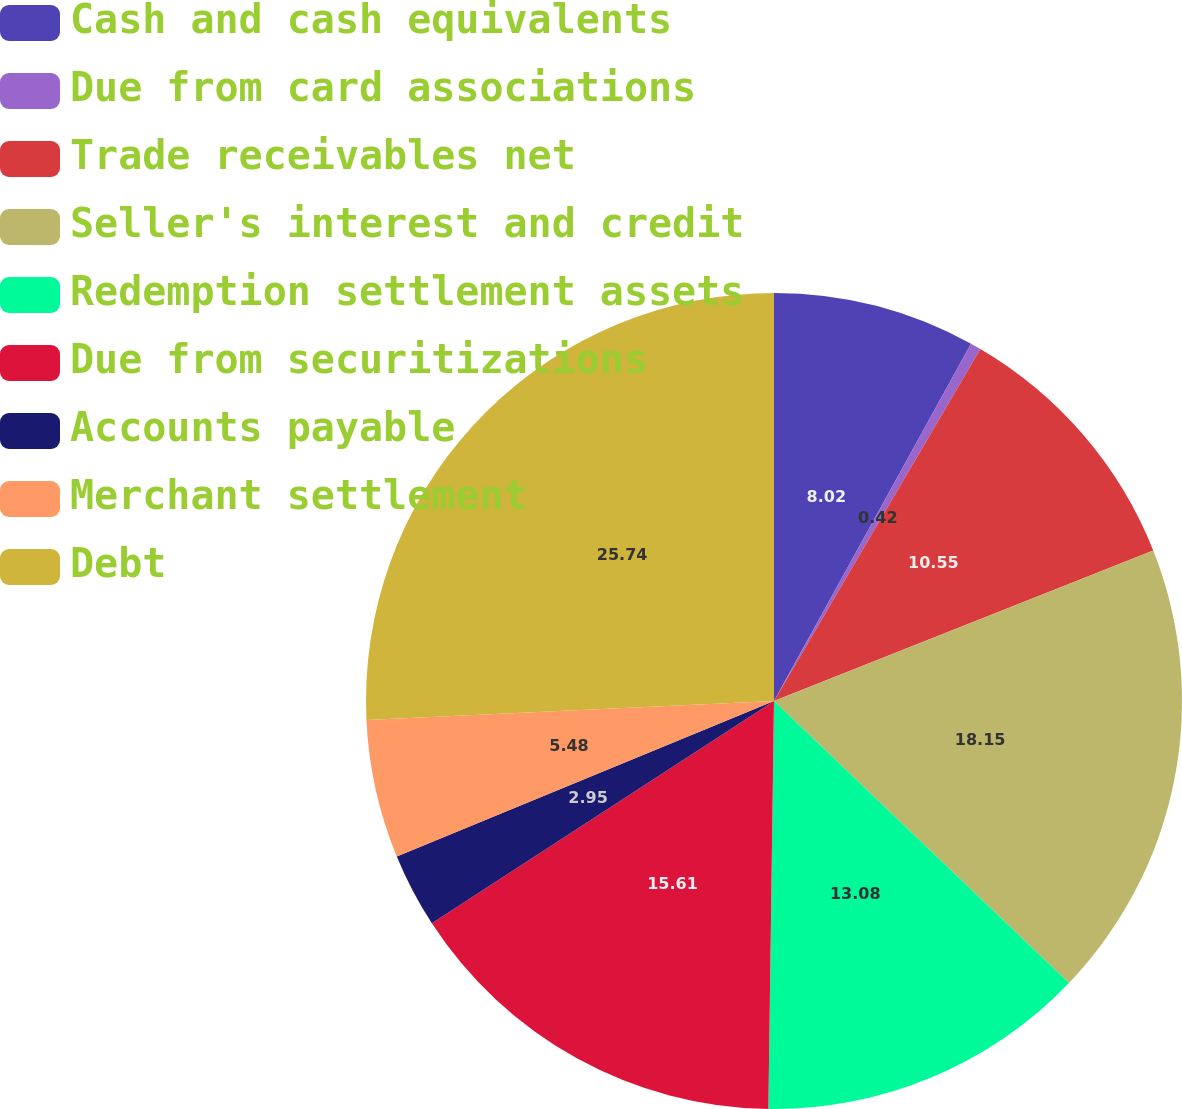Convert chart. <chart><loc_0><loc_0><loc_500><loc_500><pie_chart><fcel>Cash and cash equivalents<fcel>Due from card associations<fcel>Trade receivables net<fcel>Seller's interest and credit<fcel>Redemption settlement assets<fcel>Due from securitizations<fcel>Accounts payable<fcel>Merchant settlement<fcel>Debt<nl><fcel>8.02%<fcel>0.42%<fcel>10.55%<fcel>18.15%<fcel>13.08%<fcel>15.61%<fcel>2.95%<fcel>5.48%<fcel>25.74%<nl></chart> 